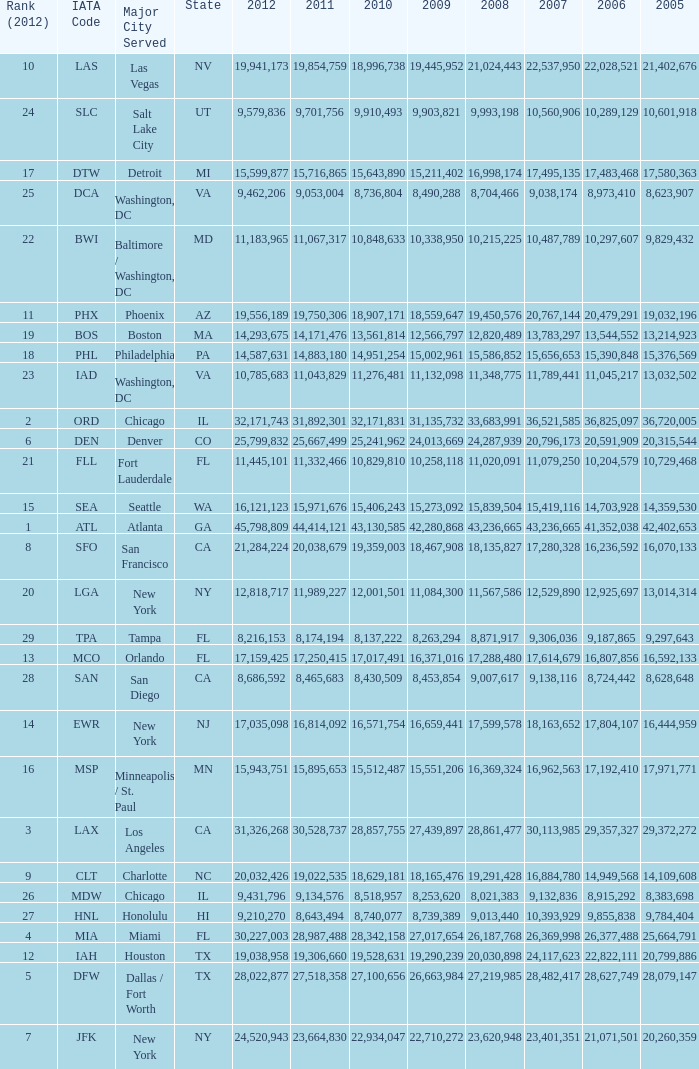For the IATA code of lax with 2009 less than 31,135,732 and 2011 less than 8,174,194, what is the sum of 2012? 0.0. Could you help me parse every detail presented in this table? {'header': ['Rank (2012)', 'IATA Code', 'Major City Served', 'State', '2012', '2011', '2010', '2009', '2008', '2007', '2006', '2005'], 'rows': [['10', 'LAS', 'Las Vegas', 'NV', '19,941,173', '19,854,759', '18,996,738', '19,445,952', '21,024,443', '22,537,950', '22,028,521', '21,402,676'], ['24', 'SLC', 'Salt Lake City', 'UT', '9,579,836', '9,701,756', '9,910,493', '9,903,821', '9,993,198', '10,560,906', '10,289,129', '10,601,918'], ['17', 'DTW', 'Detroit', 'MI', '15,599,877', '15,716,865', '15,643,890', '15,211,402', '16,998,174', '17,495,135', '17,483,468', '17,580,363'], ['25', 'DCA', 'Washington, DC', 'VA', '9,462,206', '9,053,004', '8,736,804', '8,490,288', '8,704,466', '9,038,174', '8,973,410', '8,623,907'], ['22', 'BWI', 'Baltimore / Washington, DC', 'MD', '11,183,965', '11,067,317', '10,848,633', '10,338,950', '10,215,225', '10,487,789', '10,297,607', '9,829,432'], ['11', 'PHX', 'Phoenix', 'AZ', '19,556,189', '19,750,306', '18,907,171', '18,559,647', '19,450,576', '20,767,144', '20,479,291', '19,032,196'], ['19', 'BOS', 'Boston', 'MA', '14,293,675', '14,171,476', '13,561,814', '12,566,797', '12,820,489', '13,783,297', '13,544,552', '13,214,923'], ['18', 'PHL', 'Philadelphia', 'PA', '14,587,631', '14,883,180', '14,951,254', '15,002,961', '15,586,852', '15,656,653', '15,390,848', '15,376,569'], ['23', 'IAD', 'Washington, DC', 'VA', '10,785,683', '11,043,829', '11,276,481', '11,132,098', '11,348,775', '11,789,441', '11,045,217', '13,032,502'], ['2', 'ORD', 'Chicago', 'IL', '32,171,743', '31,892,301', '32,171,831', '31,135,732', '33,683,991', '36,521,585', '36,825,097', '36,720,005'], ['6', 'DEN', 'Denver', 'CO', '25,799,832', '25,667,499', '25,241,962', '24,013,669', '24,287,939', '20,796,173', '20,591,909', '20,315,544'], ['21', 'FLL', 'Fort Lauderdale', 'FL', '11,445,101', '11,332,466', '10,829,810', '10,258,118', '11,020,091', '11,079,250', '10,204,579', '10,729,468'], ['15', 'SEA', 'Seattle', 'WA', '16,121,123', '15,971,676', '15,406,243', '15,273,092', '15,839,504', '15,419,116', '14,703,928', '14,359,530'], ['1', 'ATL', 'Atlanta', 'GA', '45,798,809', '44,414,121', '43,130,585', '42,280,868', '43,236,665', '43,236,665', '41,352,038', '42,402,653'], ['8', 'SFO', 'San Francisco', 'CA', '21,284,224', '20,038,679', '19,359,003', '18,467,908', '18,135,827', '17,280,328', '16,236,592', '16,070,133'], ['20', 'LGA', 'New York', 'NY', '12,818,717', '11,989,227', '12,001,501', '11,084,300', '11,567,586', '12,529,890', '12,925,697', '13,014,314'], ['29', 'TPA', 'Tampa', 'FL', '8,216,153', '8,174,194', '8,137,222', '8,263,294', '8,871,917', '9,306,036', '9,187,865', '9,297,643'], ['13', 'MCO', 'Orlando', 'FL', '17,159,425', '17,250,415', '17,017,491', '16,371,016', '17,288,480', '17,614,679', '16,807,856', '16,592,133'], ['28', 'SAN', 'San Diego', 'CA', '8,686,592', '8,465,683', '8,430,509', '8,453,854', '9,007,617', '9,138,116', '8,724,442', '8,628,648'], ['14', 'EWR', 'New York', 'NJ', '17,035,098', '16,814,092', '16,571,754', '16,659,441', '17,599,578', '18,163,652', '17,804,107', '16,444,959'], ['16', 'MSP', 'Minneapolis / St. Paul', 'MN', '15,943,751', '15,895,653', '15,512,487', '15,551,206', '16,369,324', '16,962,563', '17,192,410', '17,971,771'], ['3', 'LAX', 'Los Angeles', 'CA', '31,326,268', '30,528,737', '28,857,755', '27,439,897', '28,861,477', '30,113,985', '29,357,327', '29,372,272'], ['9', 'CLT', 'Charlotte', 'NC', '20,032,426', '19,022,535', '18,629,181', '18,165,476', '19,291,428', '16,884,780', '14,949,568', '14,109,608'], ['26', 'MDW', 'Chicago', 'IL', '9,431,796', '9,134,576', '8,518,957', '8,253,620', '8,021,383', '9,132,836', '8,915,292', '8,383,698'], ['27', 'HNL', 'Honolulu', 'HI', '9,210,270', '8,643,494', '8,740,077', '8,739,389', '9,013,440', '10,393,929', '9,855,838', '9,784,404'], ['4', 'MIA', 'Miami', 'FL', '30,227,003', '28,987,488', '28,342,158', '27,017,654', '26,187,768', '26,369,998', '26,377,488', '25,664,791'], ['12', 'IAH', 'Houston', 'TX', '19,038,958', '19,306,660', '19,528,631', '19,290,239', '20,030,898', '24,117,623', '22,822,111', '20,799,886'], ['5', 'DFW', 'Dallas / Fort Worth', 'TX', '28,022,877', '27,518,358', '27,100,656', '26,663,984', '27,219,985', '28,482,417', '28,627,749', '28,079,147'], ['7', 'JFK', 'New York', 'NY', '24,520,943', '23,664,830', '22,934,047', '22,710,272', '23,620,948', '23,401,351', '21,071,501', '20,260,359']]} 